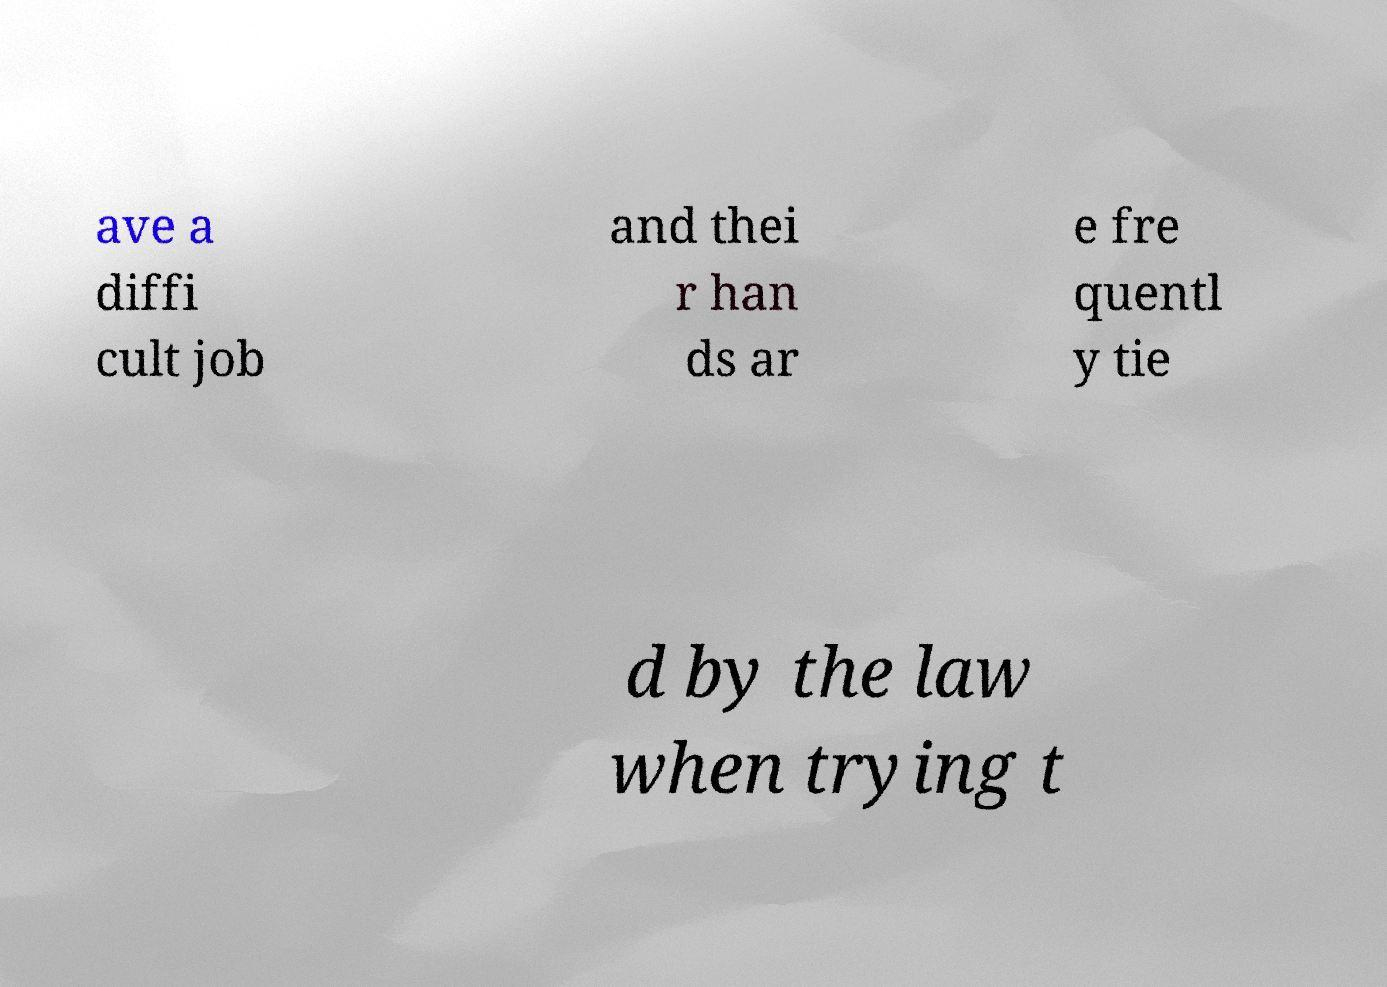For documentation purposes, I need the text within this image transcribed. Could you provide that? ave a diffi cult job and thei r han ds ar e fre quentl y tie d by the law when trying t 